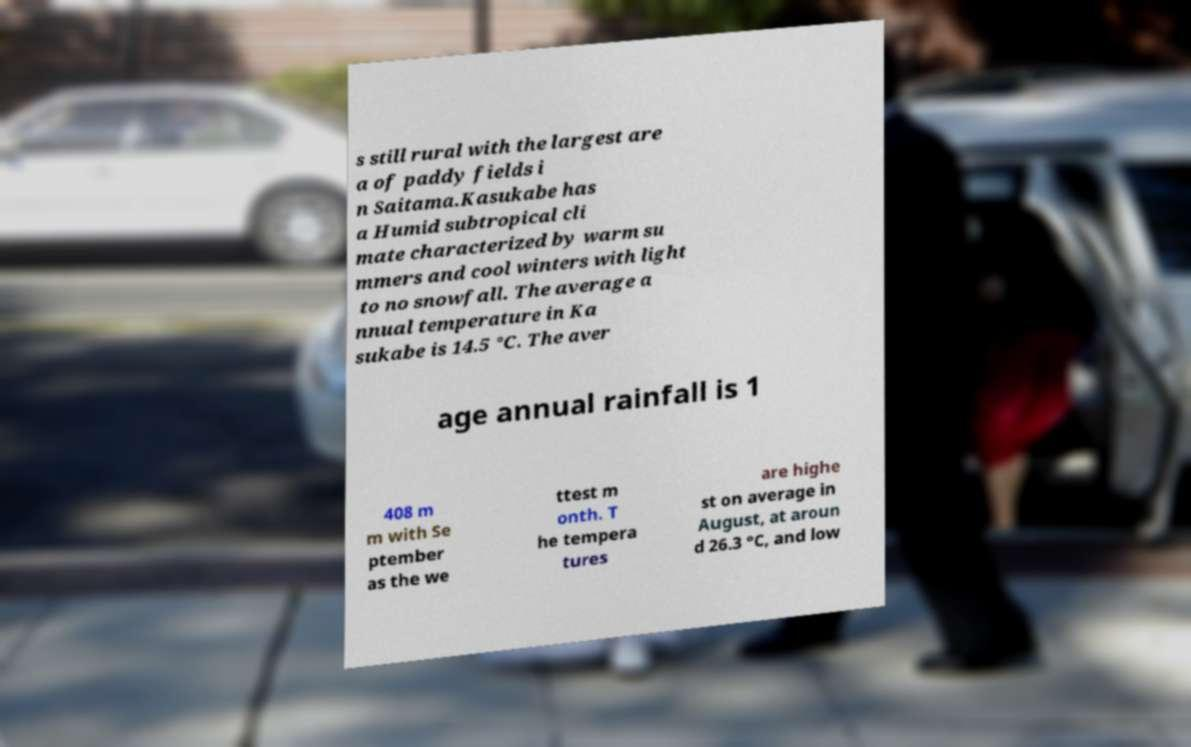Can you accurately transcribe the text from the provided image for me? s still rural with the largest are a of paddy fields i n Saitama.Kasukabe has a Humid subtropical cli mate characterized by warm su mmers and cool winters with light to no snowfall. The average a nnual temperature in Ka sukabe is 14.5 °C. The aver age annual rainfall is 1 408 m m with Se ptember as the we ttest m onth. T he tempera tures are highe st on average in August, at aroun d 26.3 °C, and low 